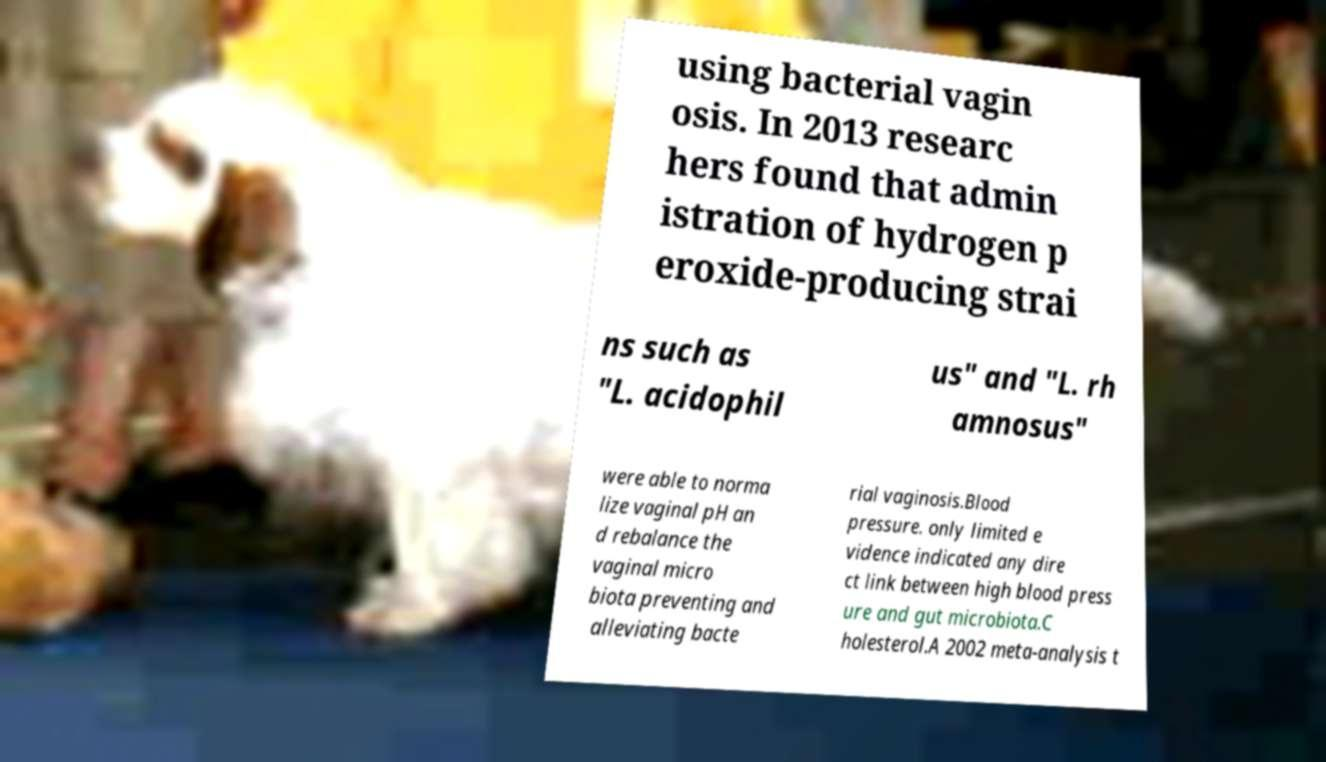Please identify and transcribe the text found in this image. using bacterial vagin osis. In 2013 researc hers found that admin istration of hydrogen p eroxide-producing strai ns such as "L. acidophil us" and "L. rh amnosus" were able to norma lize vaginal pH an d rebalance the vaginal micro biota preventing and alleviating bacte rial vaginosis.Blood pressure. only limited e vidence indicated any dire ct link between high blood press ure and gut microbiota.C holesterol.A 2002 meta-analysis t 